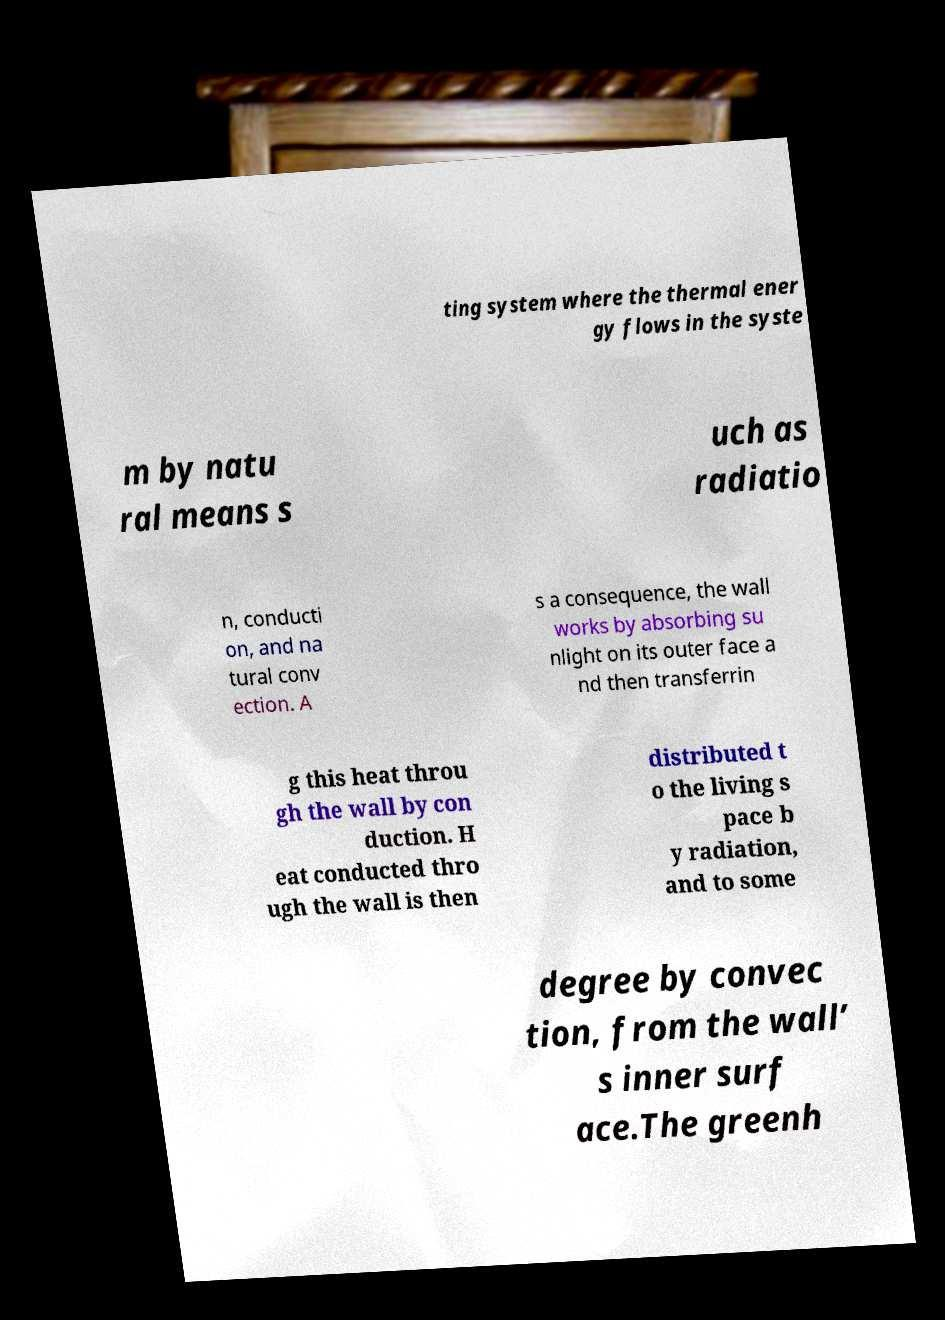Could you extract and type out the text from this image? ting system where the thermal ener gy flows in the syste m by natu ral means s uch as radiatio n, conducti on, and na tural conv ection. A s a consequence, the wall works by absorbing su nlight on its outer face a nd then transferrin g this heat throu gh the wall by con duction. H eat conducted thro ugh the wall is then distributed t o the living s pace b y radiation, and to some degree by convec tion, from the wall’ s inner surf ace.The greenh 